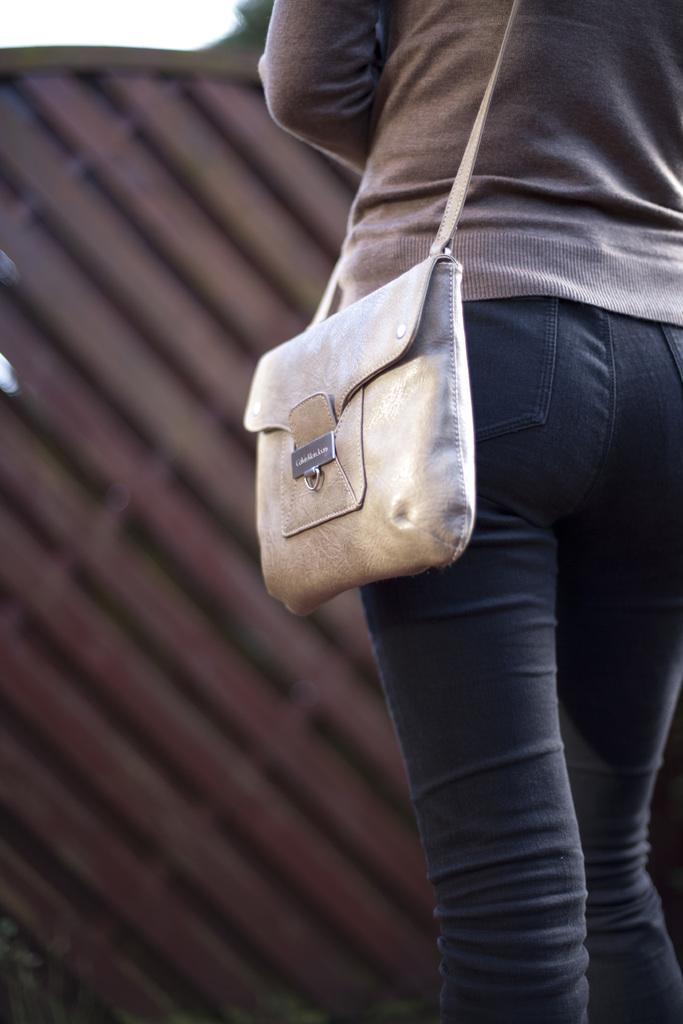Who or what is present in the image? There is a person in the image. What is the person wearing? The person is wearing a bag. What can be seen in the background of the image? There is a sky visible in the image. What is in front of the person? There is an unspecified object in front of the person. What type of bird is perched on the person's shoulder in the image? There is no bird present in the image; the person is wearing a bag. What type of seed is the person holding in the image? There is no seed present in the image; the person is wearing a bag and there is an unspecified object in front of them. 